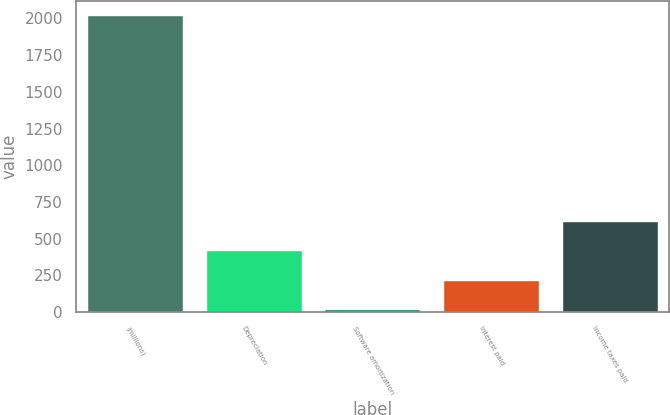Convert chart. <chart><loc_0><loc_0><loc_500><loc_500><bar_chart><fcel>(millions)<fcel>Depreciation<fcel>Software amortization<fcel>Interest paid<fcel>Income taxes paid<nl><fcel>2017<fcel>415<fcel>14.5<fcel>214.75<fcel>615.25<nl></chart> 